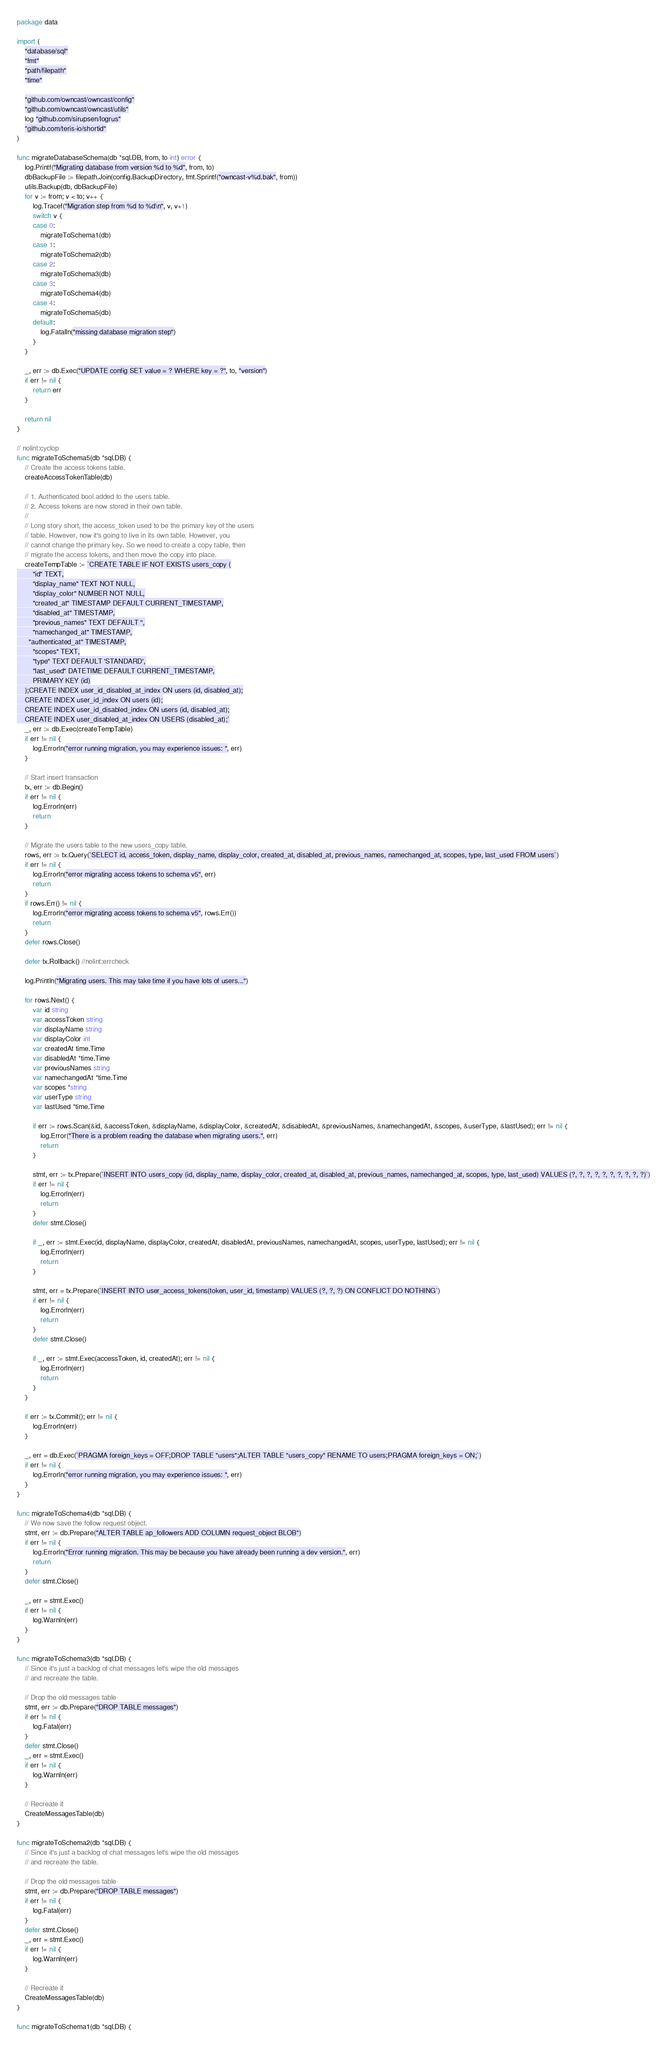<code> <loc_0><loc_0><loc_500><loc_500><_Go_>package data

import (
	"database/sql"
	"fmt"
	"path/filepath"
	"time"

	"github.com/owncast/owncast/config"
	"github.com/owncast/owncast/utils"
	log "github.com/sirupsen/logrus"
	"github.com/teris-io/shortid"
)

func migrateDatabaseSchema(db *sql.DB, from, to int) error {
	log.Printf("Migrating database from version %d to %d", from, to)
	dbBackupFile := filepath.Join(config.BackupDirectory, fmt.Sprintf("owncast-v%d.bak", from))
	utils.Backup(db, dbBackupFile)
	for v := from; v < to; v++ {
		log.Tracef("Migration step from %d to %d\n", v, v+1)
		switch v {
		case 0:
			migrateToSchema1(db)
		case 1:
			migrateToSchema2(db)
		case 2:
			migrateToSchema3(db)
		case 3:
			migrateToSchema4(db)
		case 4:
			migrateToSchema5(db)
		default:
			log.Fatalln("missing database migration step")
		}
	}

	_, err := db.Exec("UPDATE config SET value = ? WHERE key = ?", to, "version")
	if err != nil {
		return err
	}

	return nil
}

// nolint:cyclop
func migrateToSchema5(db *sql.DB) {
	// Create the access tokens table.
	createAccessTokenTable(db)

	// 1. Authenticated bool added to the users table.
	// 2. Access tokens are now stored in their own table.
	//
	// Long story short, the access_token used to be the primary key of the users
	// table. However, now it's going to live in its own table. However, you
	// cannot change the primary key. So we need to create a copy table, then
	// migrate the access tokens, and then move the copy into place.
	createTempTable := `CREATE TABLE IF NOT EXISTS users_copy (
		"id" TEXT,
		"display_name" TEXT NOT NULL,
		"display_color" NUMBER NOT NULL,
		"created_at" TIMESTAMP DEFAULT CURRENT_TIMESTAMP,
		"disabled_at" TIMESTAMP,
		"previous_names" TEXT DEFAULT '',
		"namechanged_at" TIMESTAMP,
	  "authenticated_at" TIMESTAMP,
		"scopes" TEXT,
		"type" TEXT DEFAULT 'STANDARD',
		"last_used" DATETIME DEFAULT CURRENT_TIMESTAMP,
		PRIMARY KEY (id)
	);CREATE INDEX user_id_disabled_at_index ON users (id, disabled_at);
	CREATE INDEX user_id_index ON users (id);
	CREATE INDEX user_id_disabled_index ON users (id, disabled_at);
	CREATE INDEX user_disabled_at_index ON USERS (disabled_at);`
	_, err := db.Exec(createTempTable)
	if err != nil {
		log.Errorln("error running migration, you may experience issues: ", err)
	}

	// Start insert transaction
	tx, err := db.Begin()
	if err != nil {
		log.Errorln(err)
		return
	}

	// Migrate the users table to the new users_copy table.
	rows, err := tx.Query(`SELECT id, access_token, display_name, display_color, created_at, disabled_at, previous_names, namechanged_at, scopes, type, last_used FROM users`)
	if err != nil {
		log.Errorln("error migrating access tokens to schema v5", err)
		return
	}
	if rows.Err() != nil {
		log.Errorln("error migrating access tokens to schema v5", rows.Err())
		return
	}
	defer rows.Close()

	defer tx.Rollback() //nolint:errcheck

	log.Println("Migrating users. This may take time if you have lots of users...")

	for rows.Next() {
		var id string
		var accessToken string
		var displayName string
		var displayColor int
		var createdAt time.Time
		var disabledAt *time.Time
		var previousNames string
		var namechangedAt *time.Time
		var scopes *string
		var userType string
		var lastUsed *time.Time

		if err := rows.Scan(&id, &accessToken, &displayName, &displayColor, &createdAt, &disabledAt, &previousNames, &namechangedAt, &scopes, &userType, &lastUsed); err != nil {
			log.Error("There is a problem reading the database when migrating users.", err)
			return
		}

		stmt, err := tx.Prepare(`INSERT INTO users_copy (id, display_name, display_color, created_at, disabled_at, previous_names, namechanged_at, scopes, type, last_used) VALUES (?, ?, ?, ?, ?, ?, ?, ?, ?, ?)`)
		if err != nil {
			log.Errorln(err)
			return
		}
		defer stmt.Close()

		if _, err := stmt.Exec(id, displayName, displayColor, createdAt, disabledAt, previousNames, namechangedAt, scopes, userType, lastUsed); err != nil {
			log.Errorln(err)
			return
		}

		stmt, err = tx.Prepare(`INSERT INTO user_access_tokens(token, user_id, timestamp) VALUES (?, ?, ?) ON CONFLICT DO NOTHING`)
		if err != nil {
			log.Errorln(err)
			return
		}
		defer stmt.Close()

		if _, err := stmt.Exec(accessToken, id, createdAt); err != nil {
			log.Errorln(err)
			return
		}
	}

	if err := tx.Commit(); err != nil {
		log.Errorln(err)
	}

	_, err = db.Exec(`PRAGMA foreign_keys = OFF;DROP TABLE "users";ALTER TABLE "users_copy" RENAME TO users;PRAGMA foreign_keys = ON;`)
	if err != nil {
		log.Errorln("error running migration, you may experience issues: ", err)
	}
}

func migrateToSchema4(db *sql.DB) {
	// We now save the follow request object.
	stmt, err := db.Prepare("ALTER TABLE ap_followers ADD COLUMN request_object BLOB")
	if err != nil {
		log.Errorln("Error running migration. This may be because you have already been running a dev version.", err)
		return
	}
	defer stmt.Close()

	_, err = stmt.Exec()
	if err != nil {
		log.Warnln(err)
	}
}

func migrateToSchema3(db *sql.DB) {
	// Since it's just a backlog of chat messages let's wipe the old messages
	// and recreate the table.

	// Drop the old messages table
	stmt, err := db.Prepare("DROP TABLE messages")
	if err != nil {
		log.Fatal(err)
	}
	defer stmt.Close()
	_, err = stmt.Exec()
	if err != nil {
		log.Warnln(err)
	}

	// Recreate it
	CreateMessagesTable(db)
}

func migrateToSchema2(db *sql.DB) {
	// Since it's just a backlog of chat messages let's wipe the old messages
	// and recreate the table.

	// Drop the old messages table
	stmt, err := db.Prepare("DROP TABLE messages")
	if err != nil {
		log.Fatal(err)
	}
	defer stmt.Close()
	_, err = stmt.Exec()
	if err != nil {
		log.Warnln(err)
	}

	// Recreate it
	CreateMessagesTable(db)
}

func migrateToSchema1(db *sql.DB) {</code> 